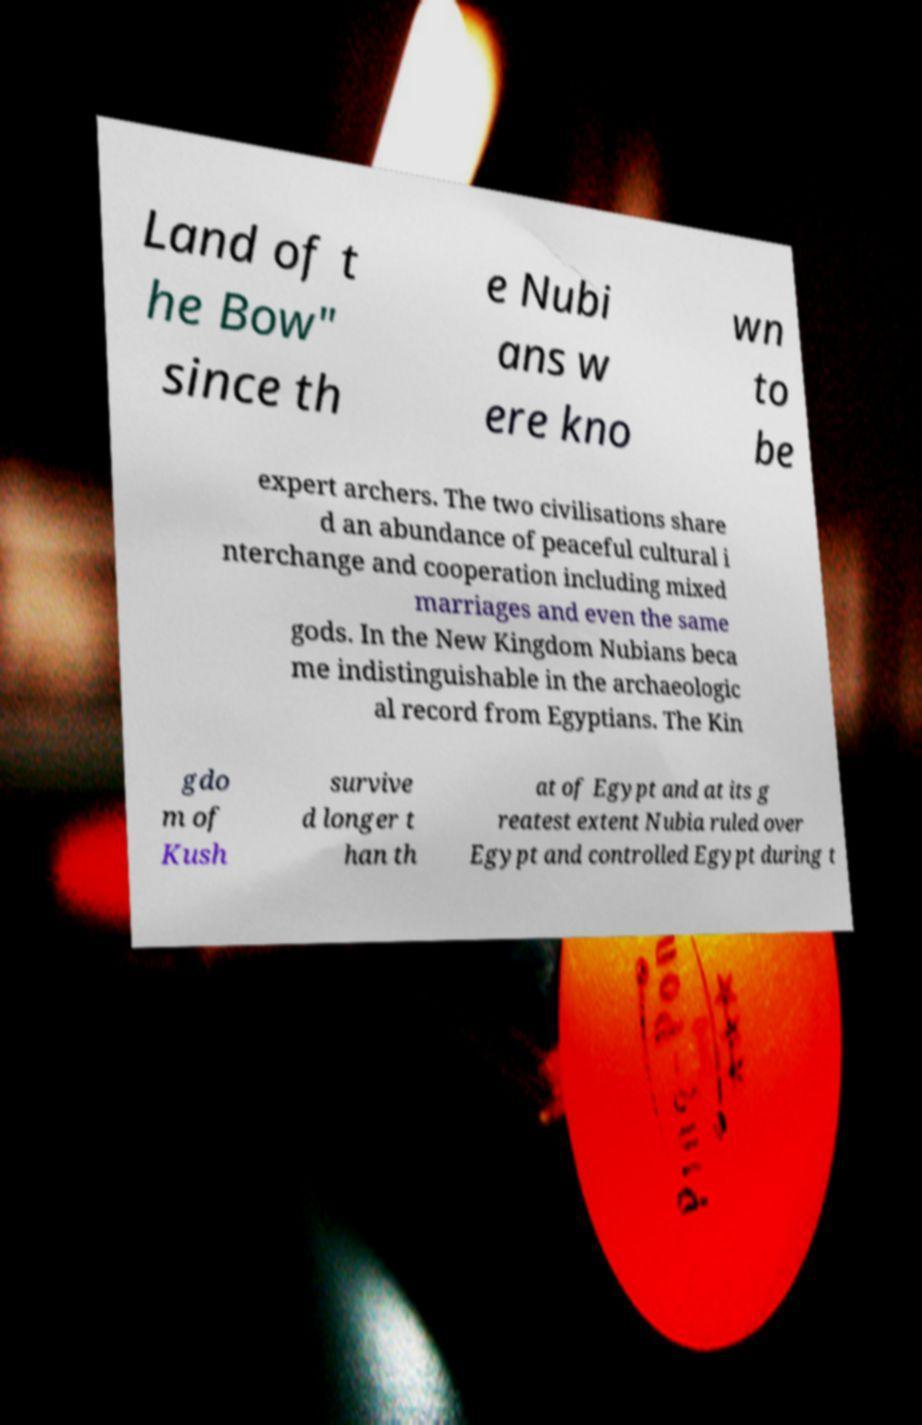Can you read and provide the text displayed in the image?This photo seems to have some interesting text. Can you extract and type it out for me? Land of t he Bow" since th e Nubi ans w ere kno wn to be expert archers. The two civilisations share d an abundance of peaceful cultural i nterchange and cooperation including mixed marriages and even the same gods. In the New Kingdom Nubians beca me indistinguishable in the archaeologic al record from Egyptians. The Kin gdo m of Kush survive d longer t han th at of Egypt and at its g reatest extent Nubia ruled over Egypt and controlled Egypt during t 